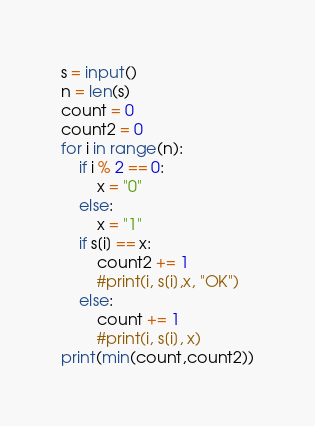<code> <loc_0><loc_0><loc_500><loc_500><_Python_>s = input()
n = len(s)
count = 0
count2 = 0
for i in range(n):
	if i % 2 == 0:
		x = "0"
	else:
		x = "1"
	if s[i] == x:
		count2 += 1 
		#print(i, s[i],x, "OK")
	else:
		count += 1
		#print(i, s[i], x)
print(min(count,count2))</code> 